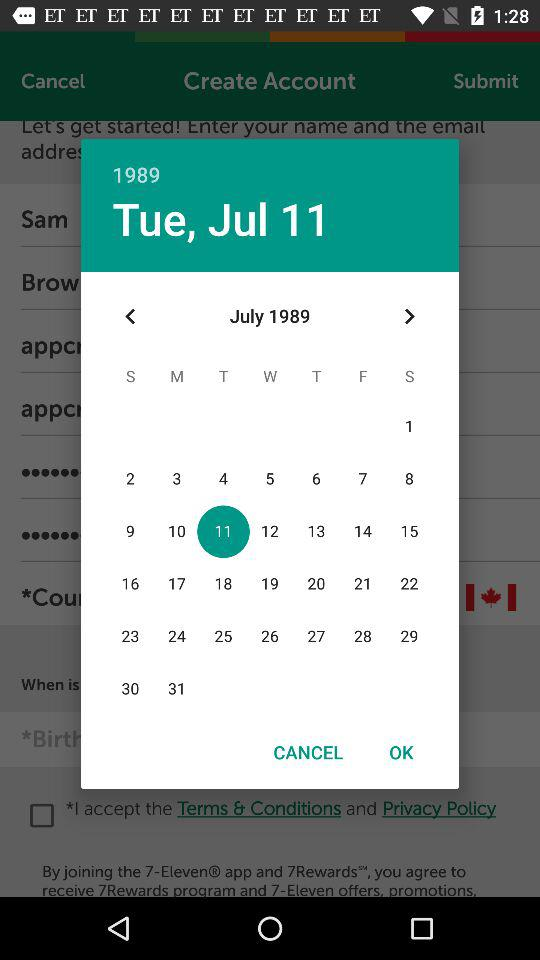What is the year? The year is 1989. 